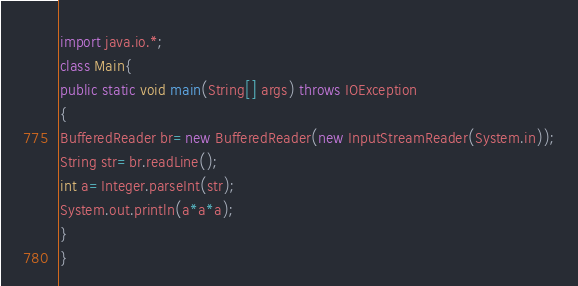<code> <loc_0><loc_0><loc_500><loc_500><_Java_>import java.io.*;
class Main{
public static void main(String[] args) throws IOException
{
BufferedReader br=new BufferedReader(new InputStreamReader(System.in));
String str=br.readLine();
int a=Integer.parseInt(str);
System.out.println(a*a*a);
}
}</code> 